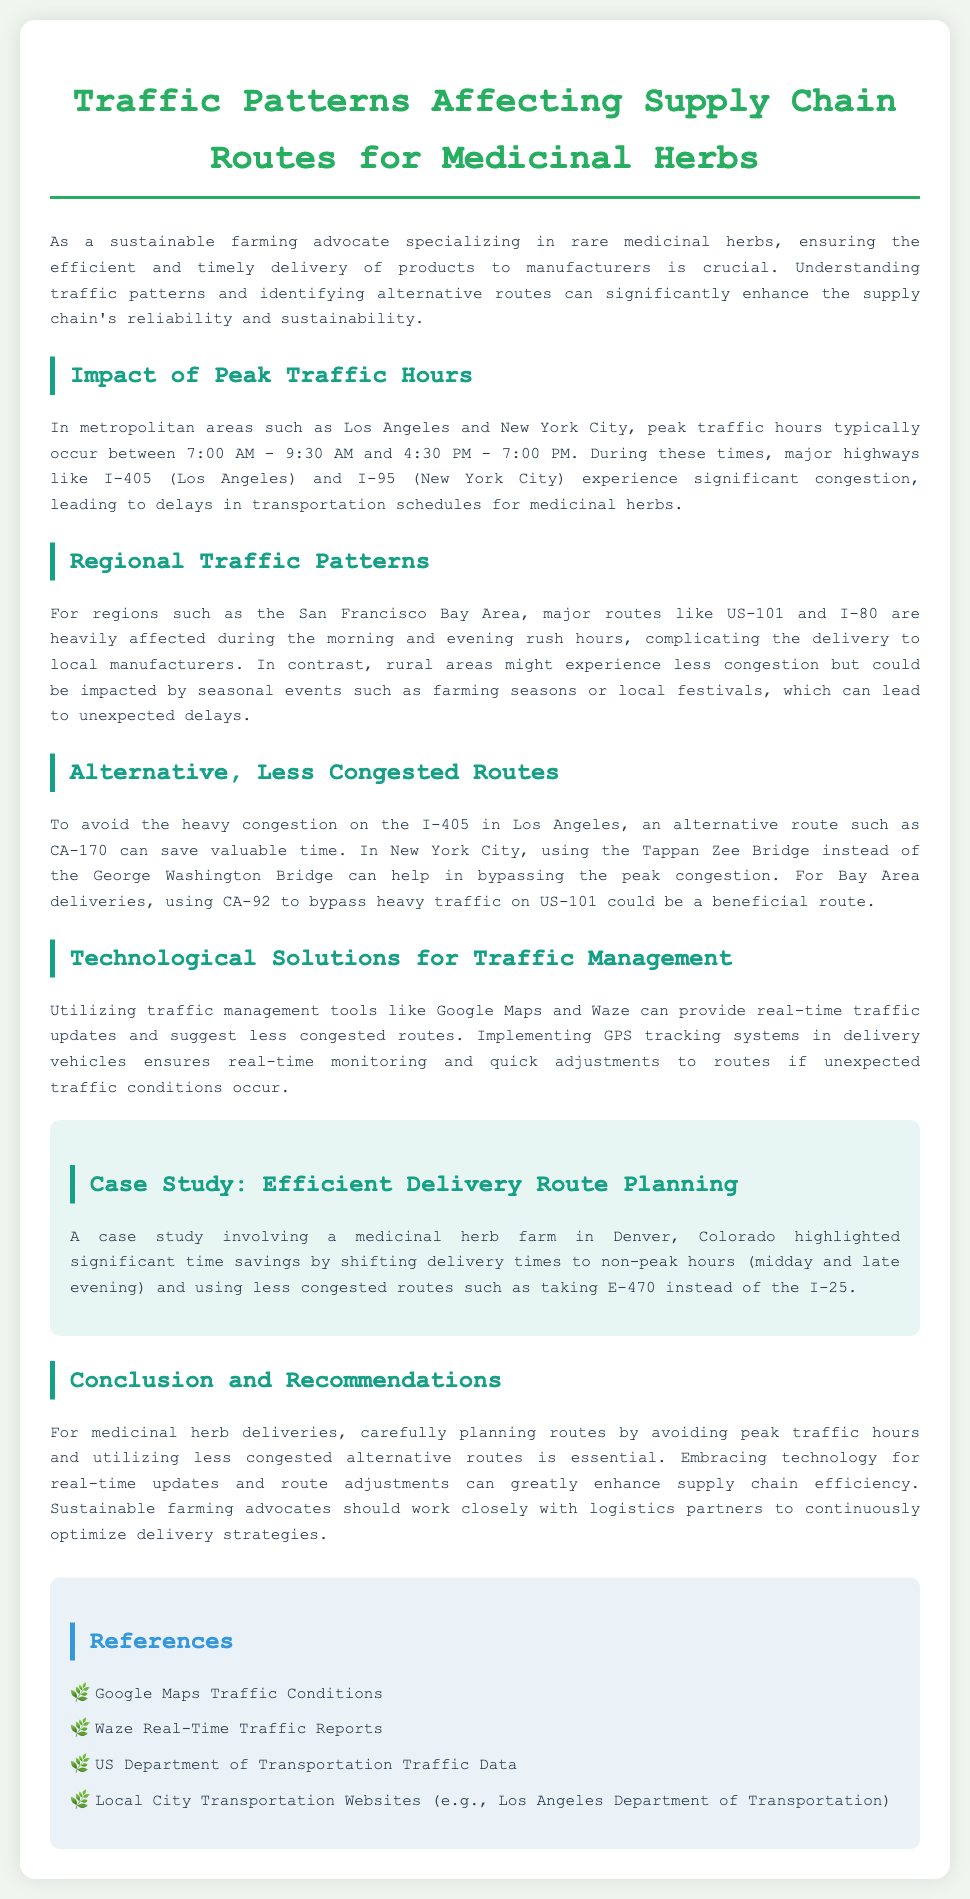what are the peak traffic hours in Los Angeles? The peak traffic hours in Los Angeles typically occur between 7:00 AM - 9:30 AM and 4:30 PM - 7:00 PM.
Answer: 7:00 AM - 9:30 AM and 4:30 PM - 7:00 PM which route can save time in Los Angeles? To avoid heavy congestion on the I-405 in Los Angeles, an alternative route such as CA-170 can save valuable time.
Answer: CA-170 what highway is heavily affected in the San Francisco Bay Area? Major routes like US-101 and I-80 are heavily affected during the morning and evening rush hours in the San Francisco Bay Area.
Answer: US-101 and I-80 how does using E-470 benefit deliveries in Denver? A case study highlighted significant time savings by shifting delivery times to non-peak hours and using less congested routes such as taking E-470 instead of the I-25.
Answer: Significant time savings what technology is recommended for traffic management? Utilizing traffic management tools like Google Maps and Waze can provide real-time updates and suggest less congested routes.
Answer: Google Maps and Waze what is the main conclusion regarding delivery routes? For medicinal herb deliveries, carefully planning routes by avoiding peak traffic hours and utilizing less congested alternative routes is essential.
Answer: Essential during which hours is the Denver delivery considered non-peak? Shifting delivery times to non-peak hours refers to midday and late evening.
Answer: Midday and late evening what should sustainable farming advocates do regarding logistics? Sustainable farming advocates should work closely with logistics partners to continuously optimize delivery strategies.
Answer: Work closely with logistics partners 